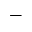<formula> <loc_0><loc_0><loc_500><loc_500>-</formula> 